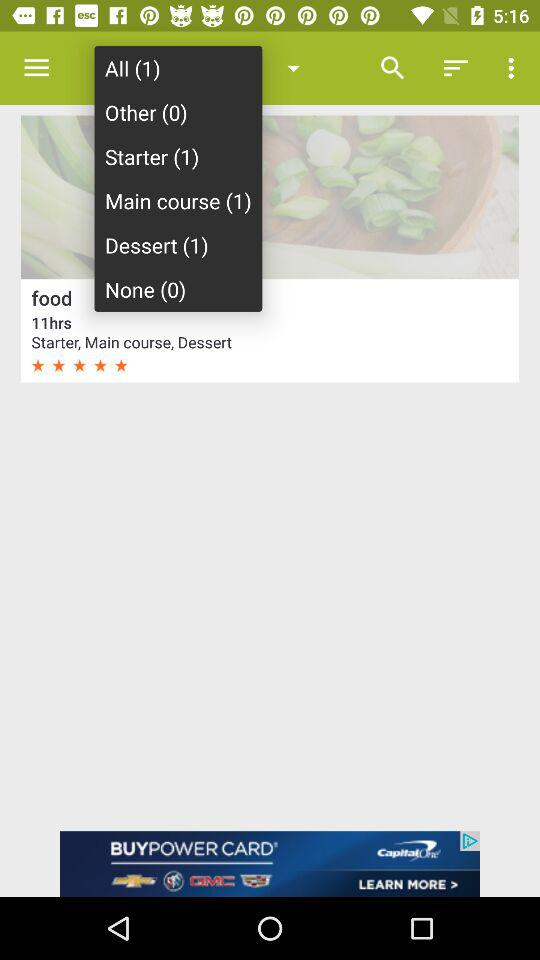What is the time duration? The time duration is 11 hours. 